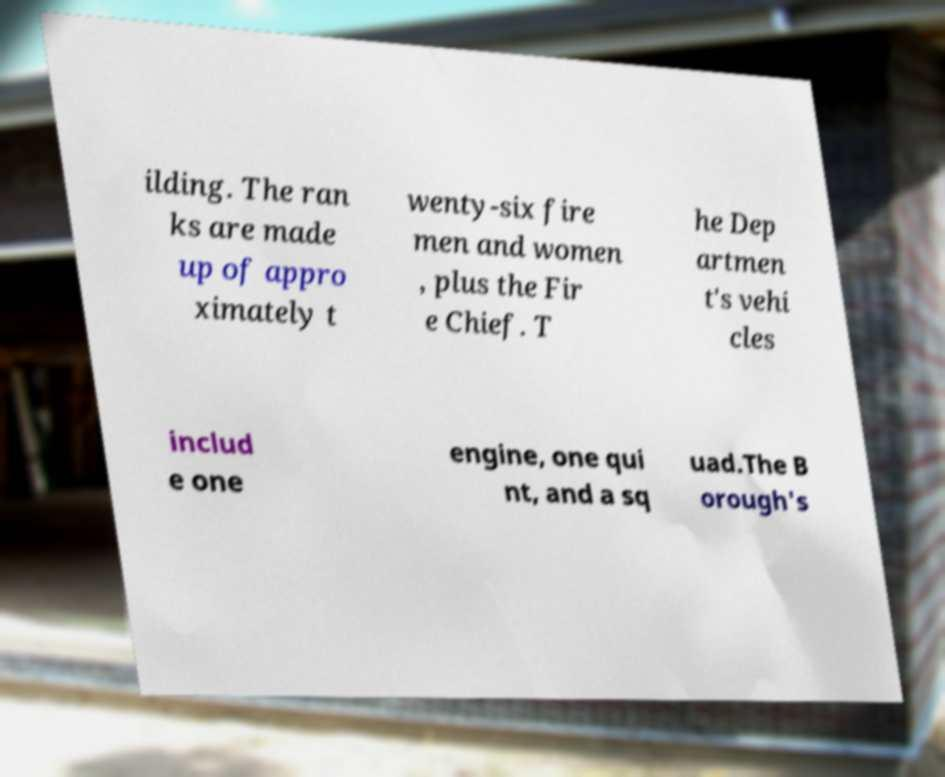There's text embedded in this image that I need extracted. Can you transcribe it verbatim? ilding. The ran ks are made up of appro ximately t wenty-six fire men and women , plus the Fir e Chief. T he Dep artmen t's vehi cles includ e one engine, one qui nt, and a sq uad.The B orough's 